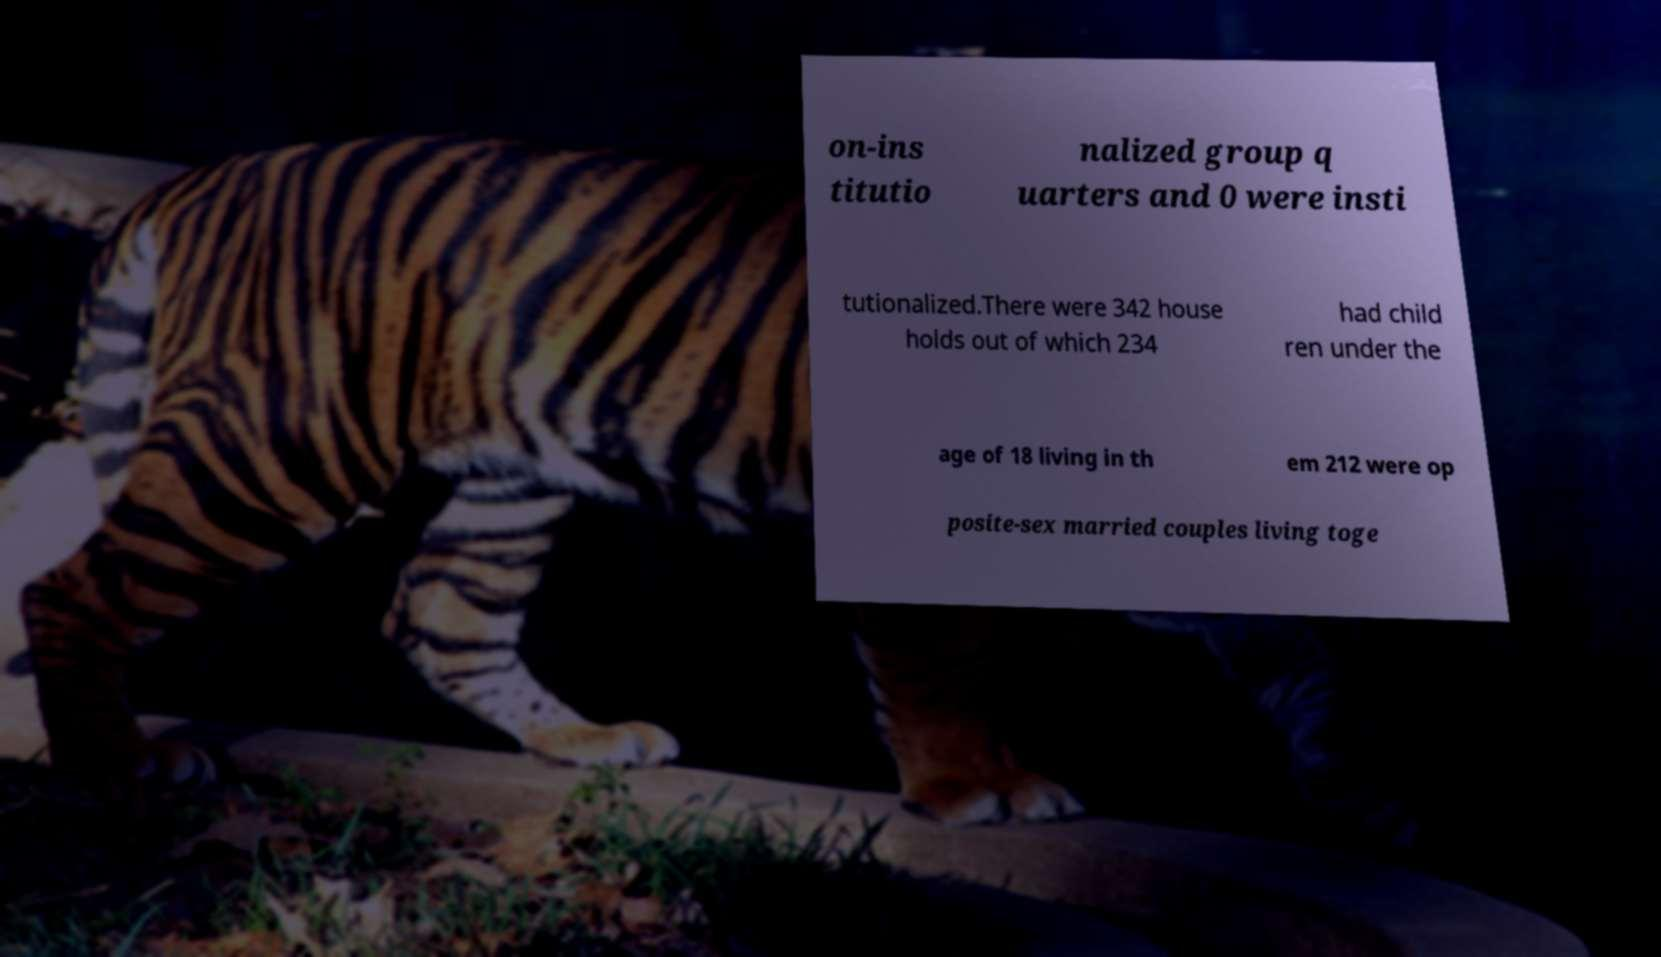There's text embedded in this image that I need extracted. Can you transcribe it verbatim? on-ins titutio nalized group q uarters and 0 were insti tutionalized.There were 342 house holds out of which 234 had child ren under the age of 18 living in th em 212 were op posite-sex married couples living toge 